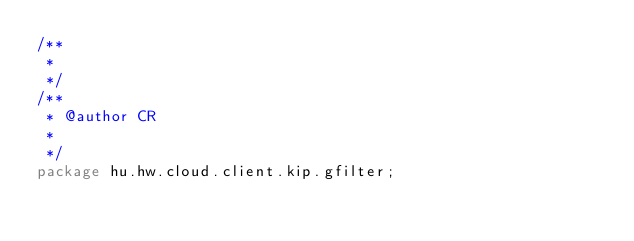<code> <loc_0><loc_0><loc_500><loc_500><_Java_>/**
 * 
 */
/**
 * @author CR
 *
 */
package hu.hw.cloud.client.kip.gfilter;</code> 